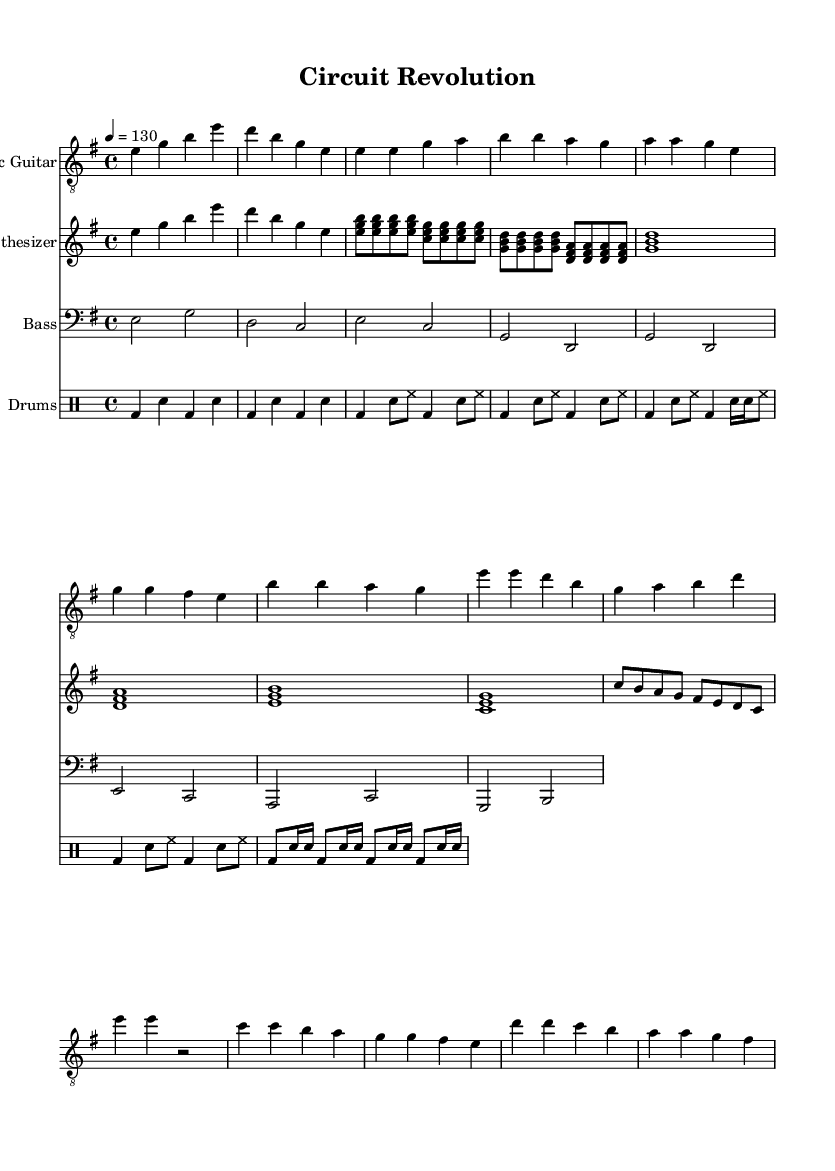What is the key signature of this music? The key signature is E minor, indicated by one sharp (F#) in the key signature area.
Answer: E minor What is the time signature of this music? The time signature is 4/4, which is indicated at the beginning of the score. It means there are four beats in a measure, and the quarter note gets one beat.
Answer: 4/4 What is the tempo of this music? The tempo is indicated as 130 beats per minute, specified at the start of the music as "4 = 130". This means that a quarter note receives 130 beats per minute.
Answer: 130 How many measures are there in the chorus? The chorus consists of 4 measures, as counted from the score section containing the chorus. Each measure has a typical structure fitting within the frame of the music notation provided.
Answer: 4 What type of instruments are used in this piece? The piece includes an electric guitar, synthesizer, bass guitar, and drums, all specifically notated at the beginning of their respective staves.
Answer: Electric guitar, synthesizer, bass guitar, drums What is the main theme of the lyrics in this piece? The main theme of the lyrics revolves around technological innovation and the concept of a revolution in circuits and electrical engineering, as seen from key phrases in the verse and chorus sections.
Answer: Technological innovation 